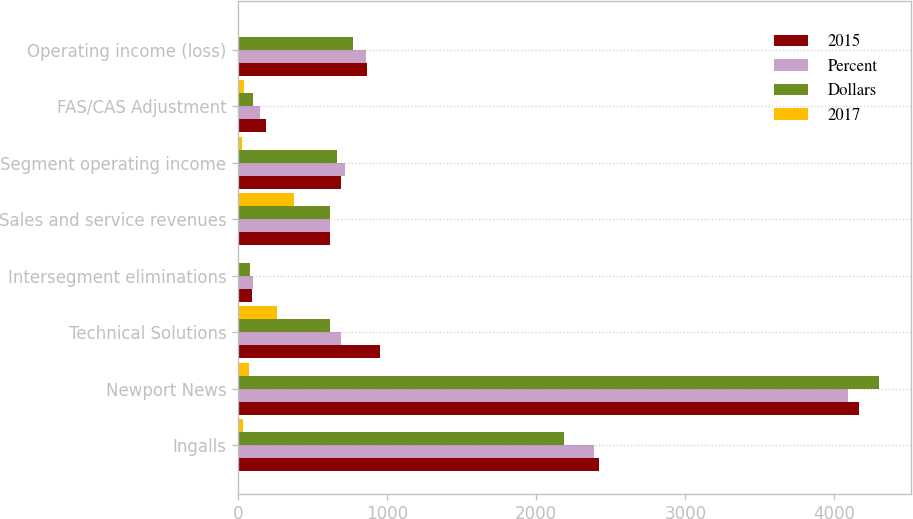Convert chart to OTSL. <chart><loc_0><loc_0><loc_500><loc_500><stacked_bar_chart><ecel><fcel>Ingalls<fcel>Newport News<fcel>Technical Solutions<fcel>Intersegment eliminations<fcel>Sales and service revenues<fcel>Segment operating income<fcel>FAS/CAS Adjustment<fcel>Operating income (loss)<nl><fcel>2015<fcel>2420<fcel>4164<fcel>952<fcel>95<fcel>616<fcel>688<fcel>189<fcel>865<nl><fcel>Percent<fcel>2389<fcel>4089<fcel>691<fcel>101<fcel>616<fcel>715<fcel>145<fcel>858<nl><fcel>Dollars<fcel>2188<fcel>4298<fcel>616<fcel>82<fcel>616<fcel>667<fcel>104<fcel>769<nl><fcel>2017<fcel>31<fcel>75<fcel>261<fcel>6<fcel>373<fcel>27<fcel>44<fcel>7<nl></chart> 